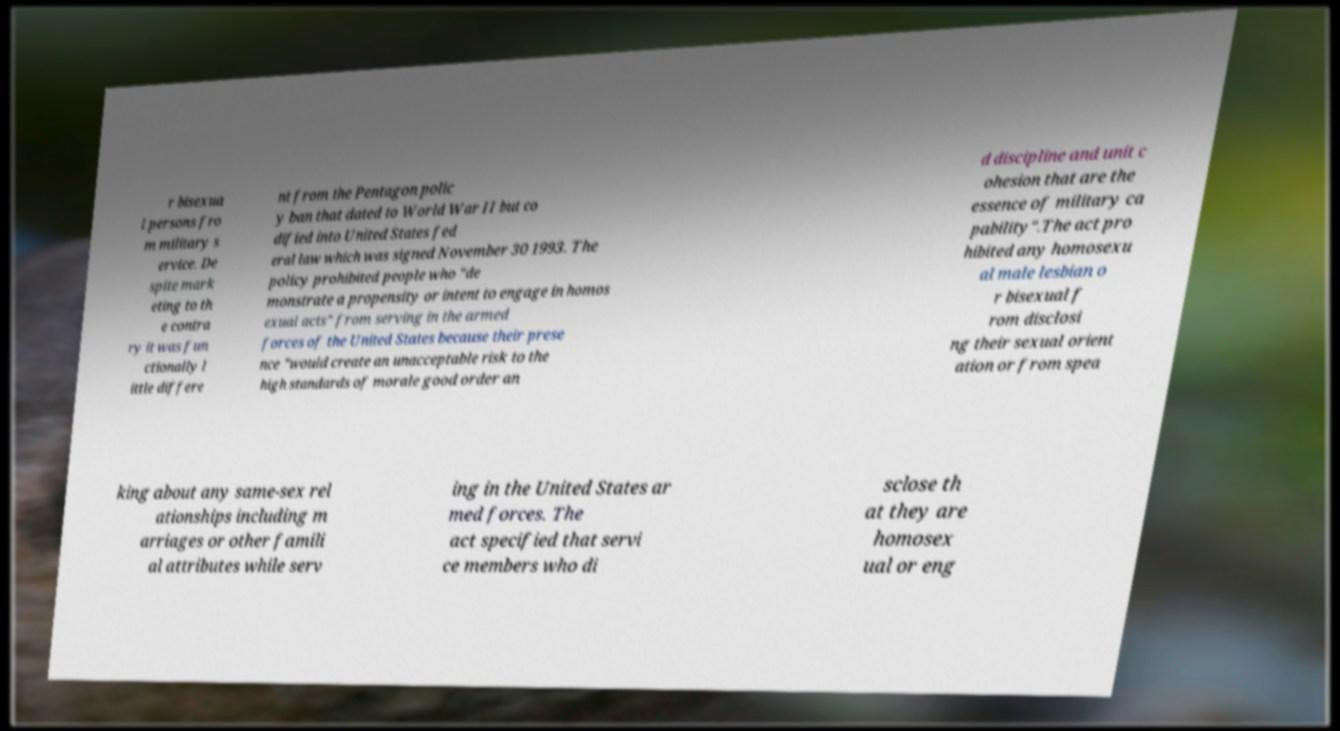For documentation purposes, I need the text within this image transcribed. Could you provide that? r bisexua l persons fro m military s ervice. De spite mark eting to th e contra ry it was fun ctionally l ittle differe nt from the Pentagon polic y ban that dated to World War II but co dified into United States fed eral law which was signed November 30 1993. The policy prohibited people who "de monstrate a propensity or intent to engage in homos exual acts" from serving in the armed forces of the United States because their prese nce "would create an unacceptable risk to the high standards of morale good order an d discipline and unit c ohesion that are the essence of military ca pability".The act pro hibited any homosexu al male lesbian o r bisexual f rom disclosi ng their sexual orient ation or from spea king about any same-sex rel ationships including m arriages or other famili al attributes while serv ing in the United States ar med forces. The act specified that servi ce members who di sclose th at they are homosex ual or eng 